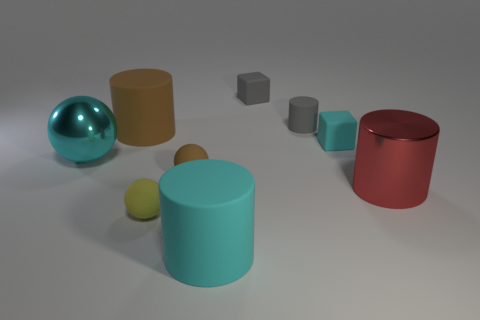What is the size of the gray thing that is the same shape as the big red metallic object?
Your answer should be compact. Small. Are there any tiny yellow objects?
Your answer should be very brief. Yes. Does the cyan matte object in front of the small yellow sphere have the same size as the cyan matte thing that is behind the big cyan rubber cylinder?
Your answer should be compact. No. There is a cyan thing that is left of the tiny gray matte block and behind the tiny brown ball; what material is it?
Offer a very short reply. Metal. There is a large cyan rubber cylinder; how many gray objects are on the right side of it?
Your response must be concise. 2. There is another tiny ball that is made of the same material as the tiny yellow ball; what is its color?
Ensure brevity in your answer.  Brown. Does the large cyan rubber thing have the same shape as the red object?
Offer a terse response. Yes. How many large shiny things are to the right of the small cyan matte thing and left of the large red cylinder?
Make the answer very short. 0. What number of rubber things are either tiny green objects or brown objects?
Keep it short and to the point. 2. What size is the cyan matte object that is behind the large cylinder that is to the right of the big cyan cylinder?
Offer a very short reply. Small. 